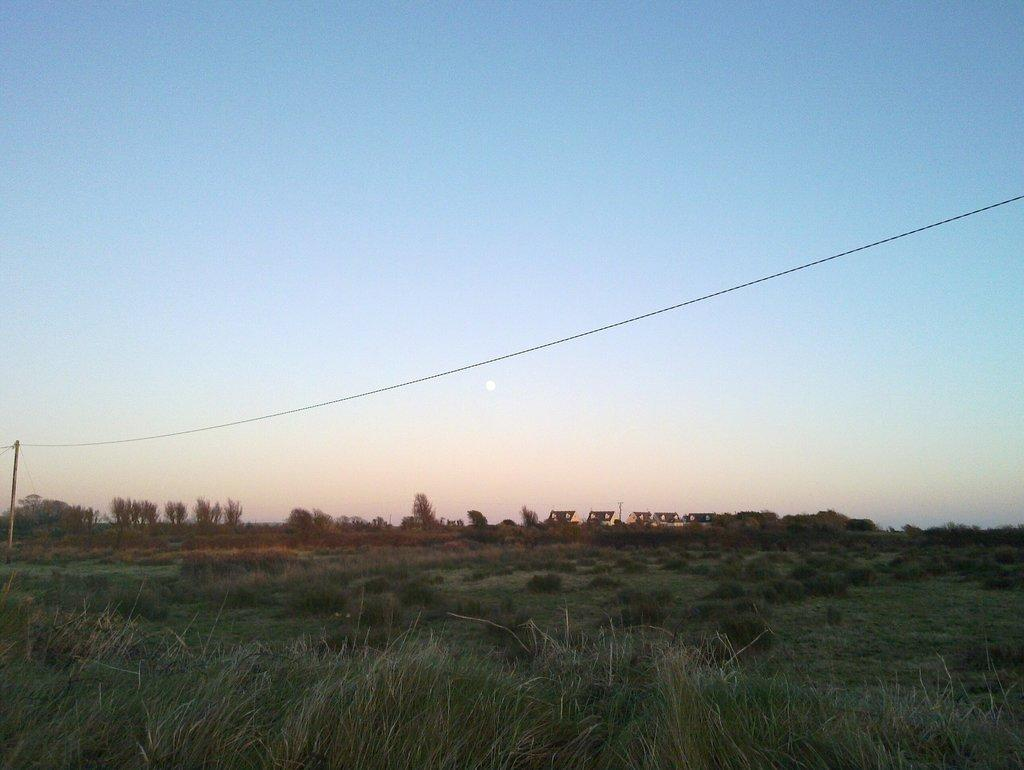What type of vegetation covers the land in the image? The land is covered with grass. What can be seen in the distance in the image? There are trees in the distance. What is the purpose of the pole with cable in the image? The pole with cable is likely a current pole, which is used to transmit electricity. What color is the sky in the image? The sky is blue in the image. What type of polish is being applied to the garden in the image? There is no garden or polish present in the image. 